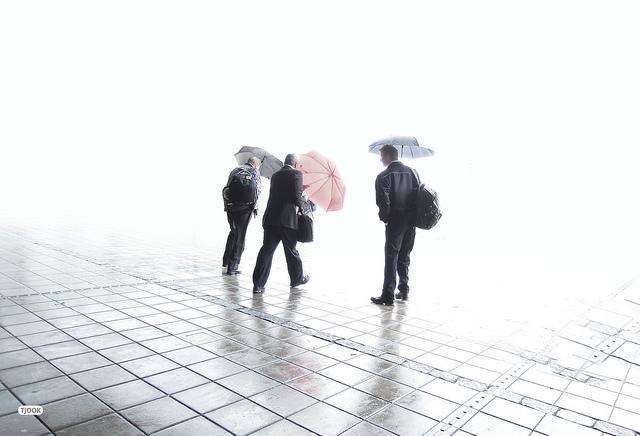How many umbrella the men are holding?
Give a very brief answer. 3. How many people are in the photo?
Give a very brief answer. 3. How many skateboards in the picture?
Give a very brief answer. 0. 